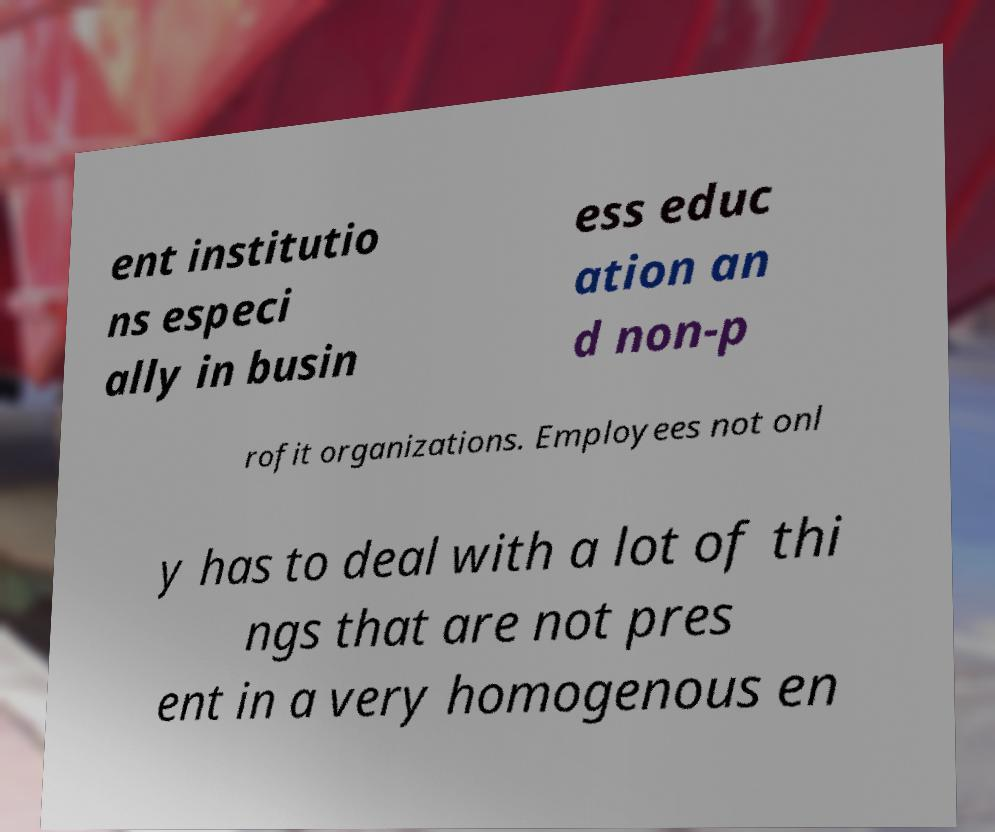For documentation purposes, I need the text within this image transcribed. Could you provide that? ent institutio ns especi ally in busin ess educ ation an d non-p rofit organizations. Employees not onl y has to deal with a lot of thi ngs that are not pres ent in a very homogenous en 